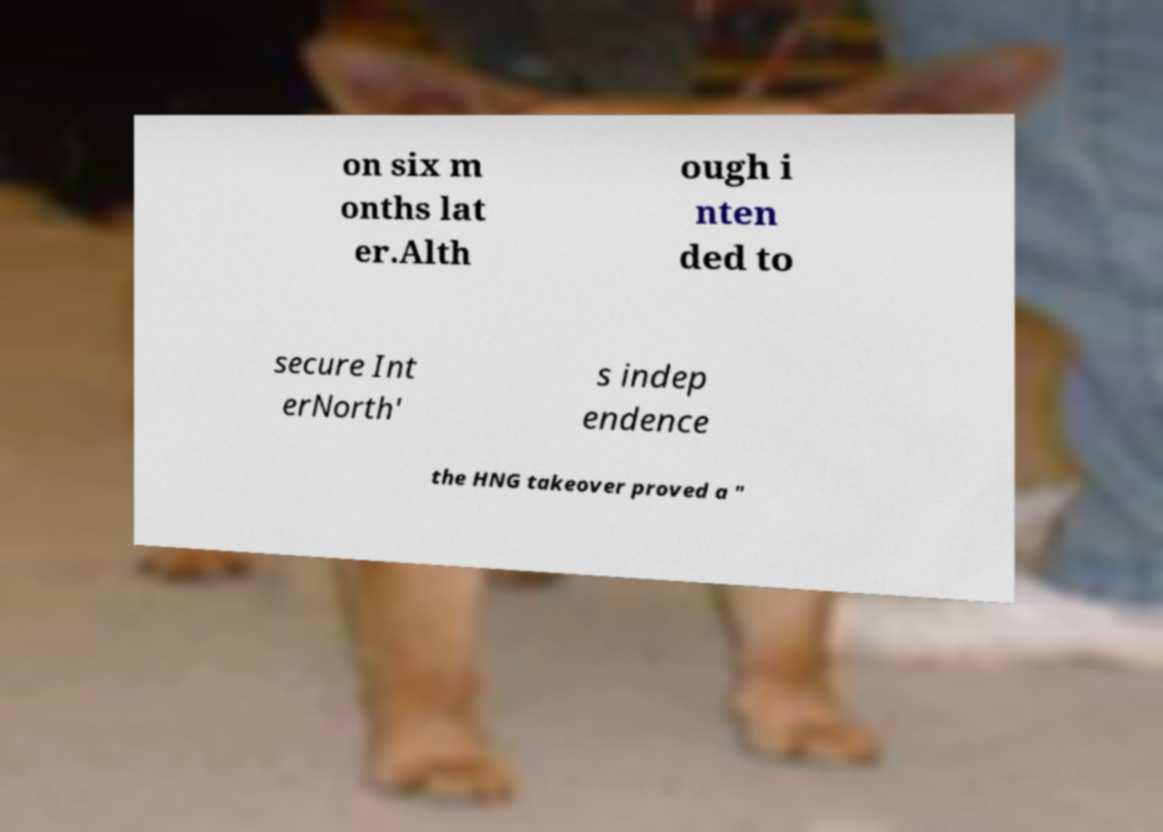What messages or text are displayed in this image? I need them in a readable, typed format. on six m onths lat er.Alth ough i nten ded to secure Int erNorth' s indep endence the HNG takeover proved a " 